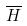<formula> <loc_0><loc_0><loc_500><loc_500>\overline { H }</formula> 